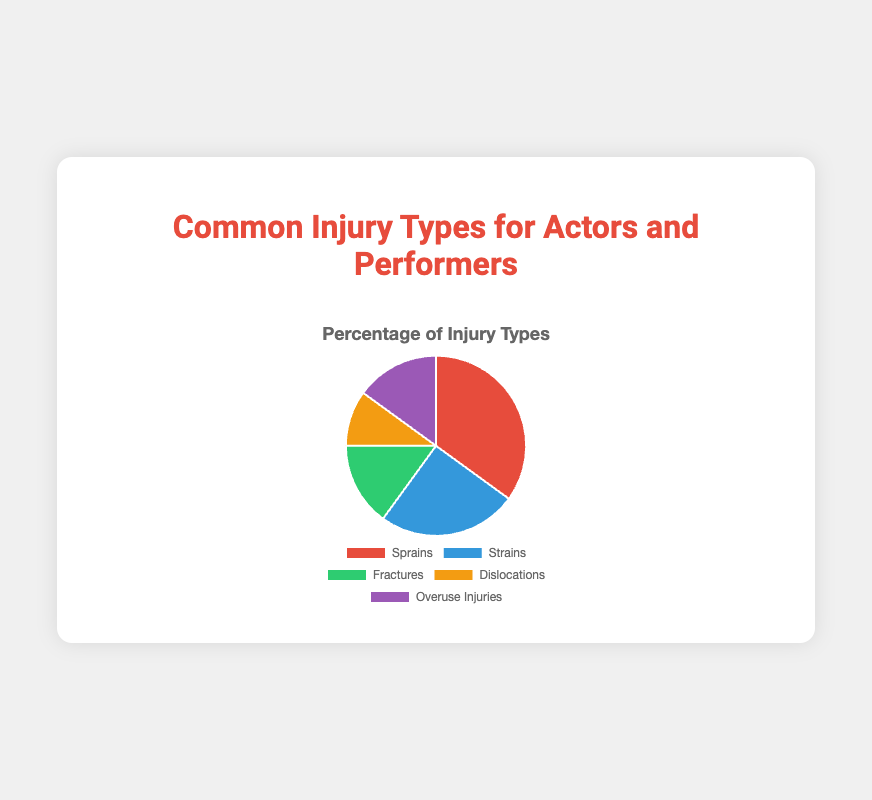Which injury type is the most common? The pie chart shows the injury types, and the largest segment represents sprains with a percentage of 35%.
Answer: Sprains Among strains and fractures, which injury type is less common? Comparing the percentages from the chart, strains have 25% while fractures have 15%. Thus, fractures are less common.
Answer: Fractures What is the total percentage of injuries accounted for by fractures and overuse injuries? Add the percentages for fractures (15%) and overuse injuries (15%). The total is 15% + 15% = 30%.
Answer: 30% Which two injury types together form the largest combined percentage? Check the possible combinations: 
Sprains (35%) + Strains (25%) = 60%; 
Sprains (35%) + Fractures (15%) = 50%; 
Sprains (35%) + Dislocations (10%) = 45%; 
Sprains (35%) + Overuse Injuries (15%) = 50%. 
So, the largest combined is Sprains and Strains with 60%.
Answer: Sprains and Strains What is the combined percentage of the three least common injury types? Add the percentages for the three least common types, which are fractures (15%), dislocations (10%), and overuse injuries (15%). The total is 15% + 10% + 15% = 40%.
Answer: 40% How is the visual segment representing dislocations colored? The pie chart segment for dislocations is colored in an orange-yellow shade.
Answer: Orange-Yellow Which injury type accounts for 1/4 of all injuries? The pie chart shows Strains with 25%, which is equivalent to one-fourth.
Answer: Strains Which is more common, overuse injuries or dislocations? According to the chart, overuse injuries are at 15%, and dislocations are at 10%. So, overuse injuries are more common.
Answer: Overuse Injuries By how much is the percentage of strains less than sprains? Subtract the percentage of strains (25%) from sprains (35%). The difference is 35% - 25% = 10%.
Answer: 10% If the sum percentage of fractures and dislocations equals the percentage of another injury type, which is it? Add the percentages of fractures (15%) and dislocations (10%). The total is 15% + 10% = 25%, which equals the percentage for strains.
Answer: Strains 